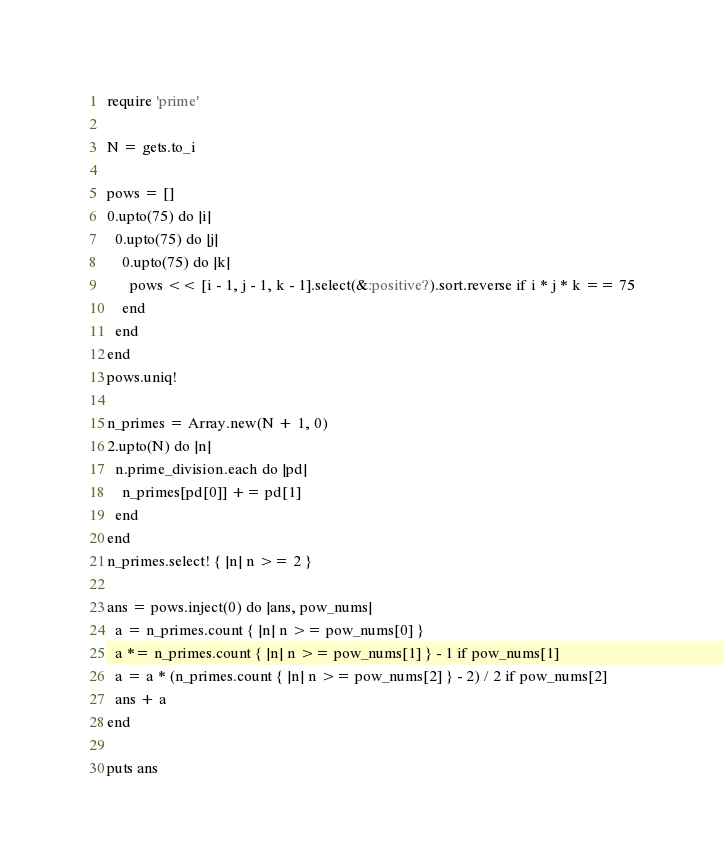<code> <loc_0><loc_0><loc_500><loc_500><_Ruby_>require 'prime'

N = gets.to_i

pows = []
0.upto(75) do |i|
  0.upto(75) do |j|
    0.upto(75) do |k|
      pows << [i - 1, j - 1, k - 1].select(&:positive?).sort.reverse if i * j * k == 75
    end
  end
end
pows.uniq!

n_primes = Array.new(N + 1, 0)
2.upto(N) do |n|
  n.prime_division.each do |pd|
    n_primes[pd[0]] += pd[1]
  end
end
n_primes.select! { |n| n >= 2 }

ans = pows.inject(0) do |ans, pow_nums|
  a = n_primes.count { |n| n >= pow_nums[0] }
  a *= n_primes.count { |n| n >= pow_nums[1] } - 1 if pow_nums[1]
  a = a * (n_primes.count { |n| n >= pow_nums[2] } - 2) / 2 if pow_nums[2]
  ans + a
end

puts ans</code> 